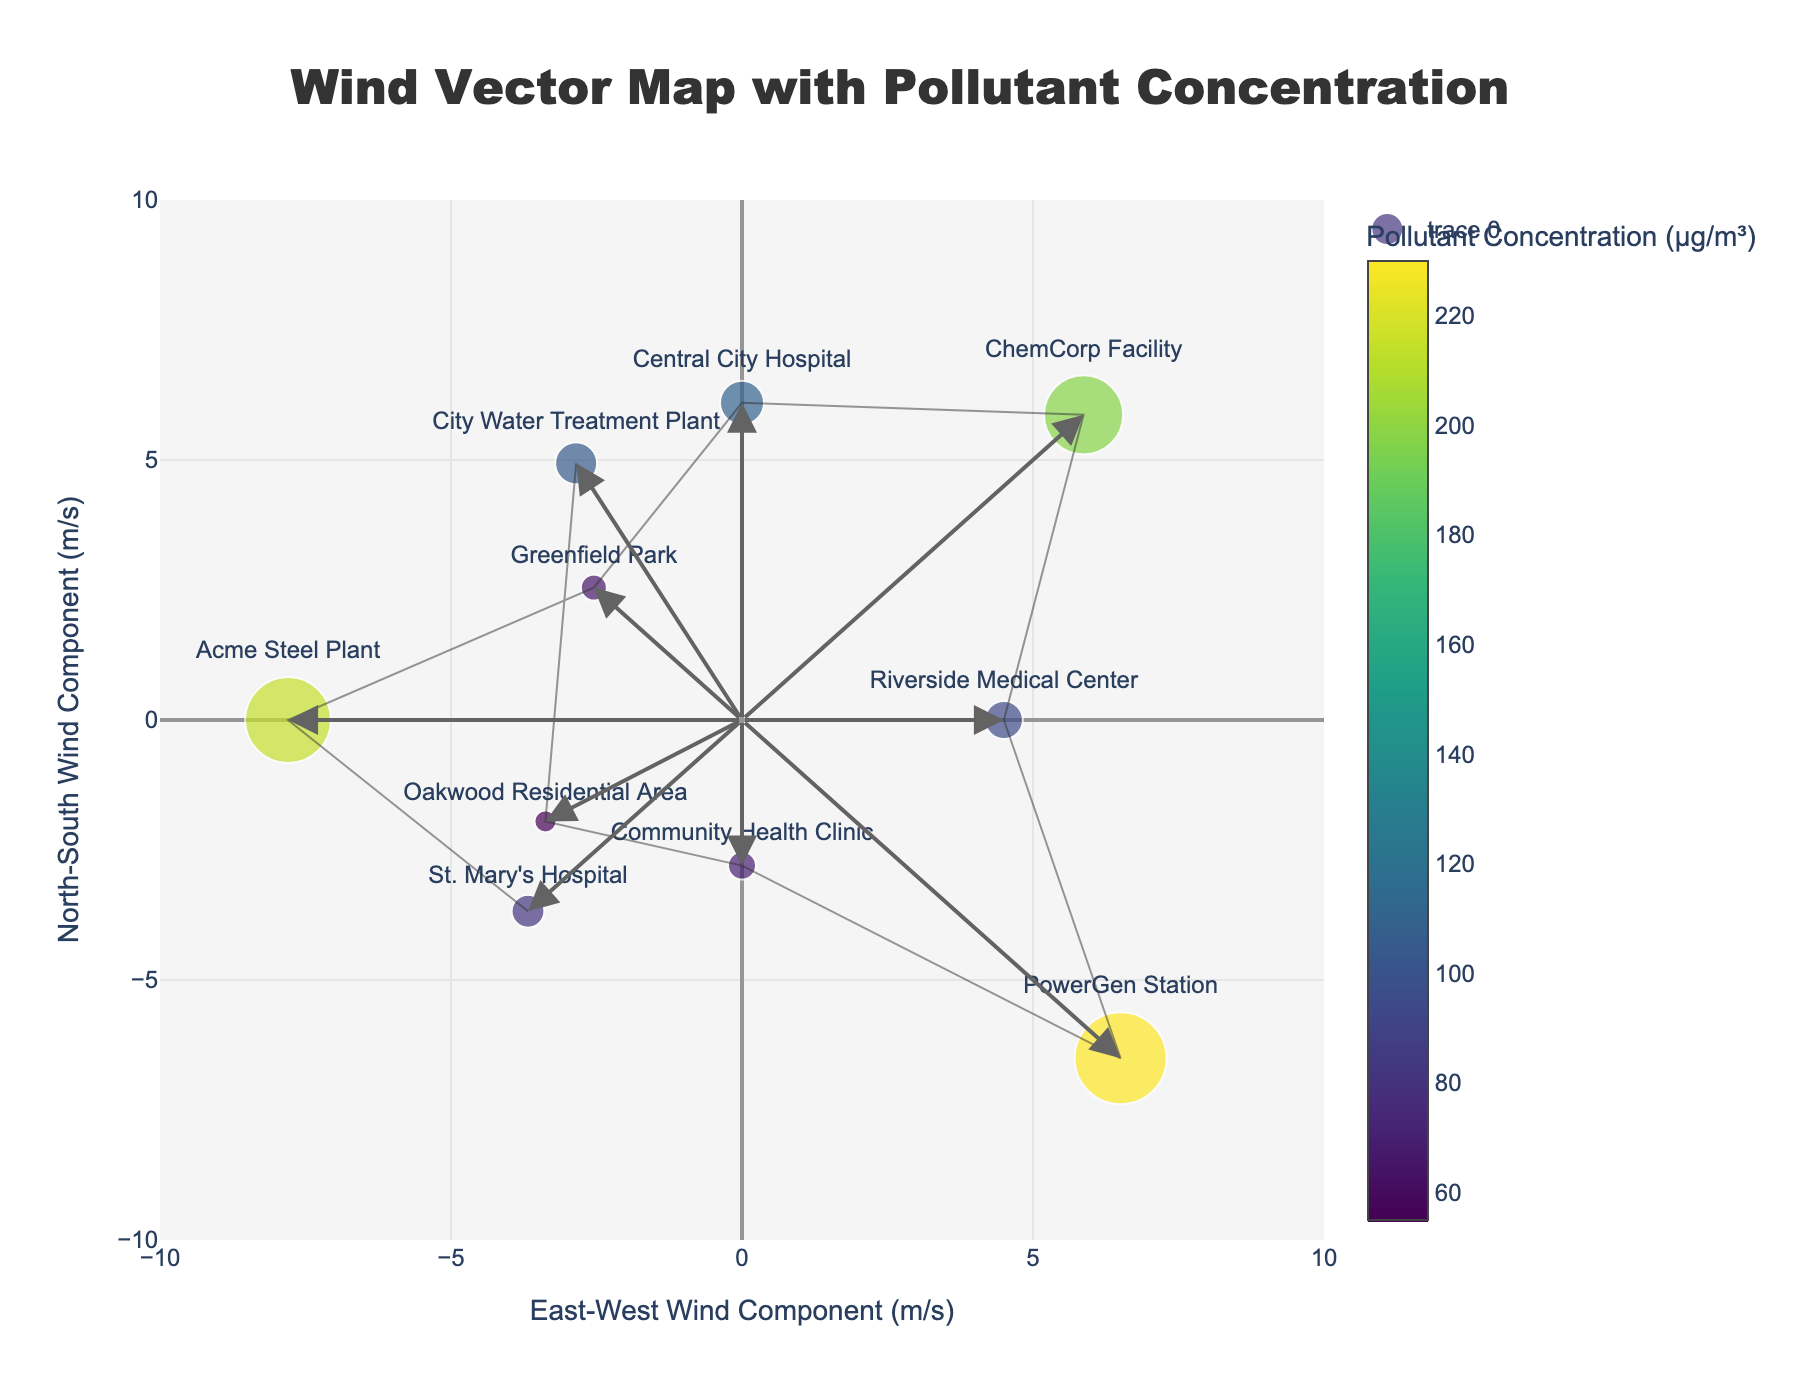What is the title of the figure? The title of the figure is situated at the top. It reads "Wind Vector Map with Pollutant Concentration".
Answer: Wind Vector Map with Pollutant Concentration Which location has the highest pollutant concentration? The size of the markers represents the pollutant concentration, and the color intensity of the marker also indicates high pollutant levels. The largest, darkest marker corresponds to the PowerGen Station.
Answer: PowerGen Station What are the East-West and North-South wind components for the ChemCorp Facility? The East-West component (u) and North-South component (v) are calculated for each location using wind speed and direction. For ChemCorp Facility, u = 8.3 * sin(225°) = -5.87, v = 8.3 * cos(225°) = -5.87.
Answer: u ≈ -5.87, v ≈ -5.87 Compare the wind speed at Riverside Medical Center and Central City Hospital. Which one is higher? By examining the hovertext associated with each marker: Riverside Medical Center shows 4.5 m/s and Central City Hospital shows 6.1 m/s. Therefore, the wind speed is higher at Central City Hospital.
Answer: Central City Hospital How does wind direction potentially influence pollutant dispersal from the Acme Steel Plant to Riverside Medical Center? Wind from the Acme Steel Plant is moving at a 90° (east direction), and the Riverside Medical Center is influenced by a 270° (west direction) wind. These opposing directions imply pollutants from the east (Acme Steel Plant) should stay separated from those moving west (Riverside Medical Center).
Answer: Opposing directions, unlikely direct influence What's the general trend between wind speed and pollutant concentration? By observing marker sizes and colors, we can infer that locations with higher wind speeds (e.g., PowerGen Station with 9.2 m/s) often have higher pollutant concentrations, suggesting that higher wind speeds might correspond with elevated pollutant dispersal.
Answer: Higher wind speed correlates with higher pollutant concentration Which location has the most northern component of the wind vector? The most northern component would have the highest positive value on the North-South wind component axis (y-axis). Community Health Clinic displays this, as its wind direction is 0° (north).
Answer: Community Health Clinic What is the average pollutant concentration across all locations? Summing pollutant concentrations: 82 + 215 + 65 + 110 + 198 + 95 + 230 + 70 + 55 + 105 = 1225. There are 10 locations, so the average is 1225/10.
Answer: 122.5 μg/m³ Is there a relationship between the wind vector components and pollutant concentrations near hospitals? Focusing on hospital locations: St. Mary's Hospital, Central City Hospital, and Riverside Medical Center. Wind vectors do not show a consistent directional pattern, but higher pollutant concentrations are noticeable near industrial sites like Central City Hospital.
Answer: No consistent directional pattern, but higher concentrations near industrial sites Which industrial facility shows the strongest winds, and what might this indicate about pollutant spread? By looking at the hovertexts, PowerGen Station shows the strongest winds at 9.2 m/s. Higher wind speed could indicate a broader spread of pollutants from this facility.
Answer: PowerGen Station 